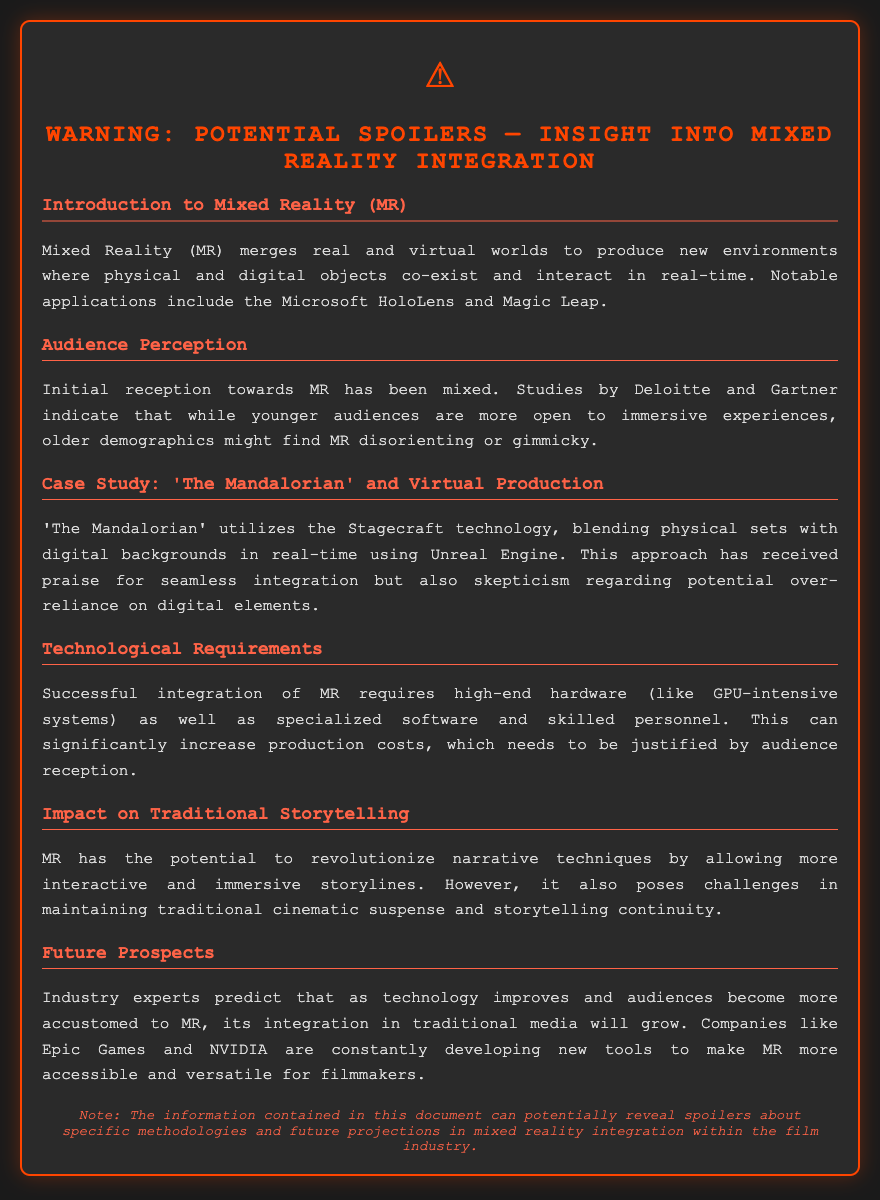What is Mixed Reality (MR)? MR merges real and virtual worlds to produce new environments where physical and digital objects co-exist and interact in real-time.
Answer: MR merges real and virtual worlds What technology does 'The Mandalorian' utilize? 'The Mandalorian' utilizes the Stagecraft technology, which blends physical sets with digital backgrounds.
Answer: Stagecraft Which demographics are more open to immersive experiences? Studies indicate that younger audiences are more open to immersive experiences.
Answer: Younger audiences What are the challenges posed by MR to traditional storytelling? MR poses challenges in maintaining traditional cinematic suspense and storytelling continuity.
Answer: Cinematic suspense and storytelling continuity What do industry experts predict about the future of MR? Industry experts predict that as technology improves, its integration in traditional media will grow.
Answer: Integration will grow 